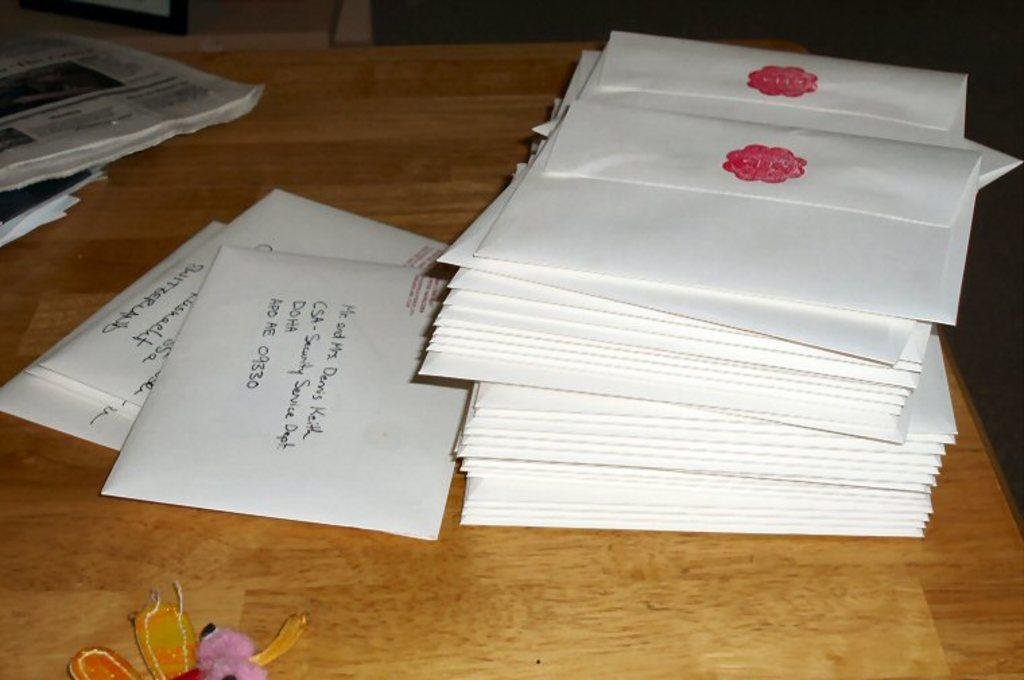<image>
Write a terse but informative summary of the picture. envelopes on a desk with one addressed to Mr and Mrs Dennis Keith 